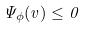<formula> <loc_0><loc_0><loc_500><loc_500>\Psi _ { \phi } ( v ) \leq 0</formula> 